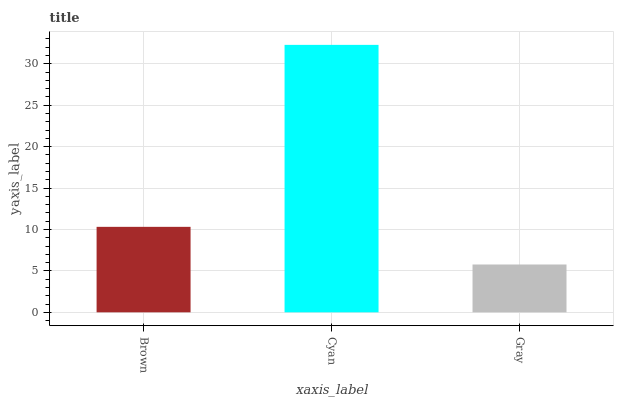Is Gray the minimum?
Answer yes or no. Yes. Is Cyan the maximum?
Answer yes or no. Yes. Is Cyan the minimum?
Answer yes or no. No. Is Gray the maximum?
Answer yes or no. No. Is Cyan greater than Gray?
Answer yes or no. Yes. Is Gray less than Cyan?
Answer yes or no. Yes. Is Gray greater than Cyan?
Answer yes or no. No. Is Cyan less than Gray?
Answer yes or no. No. Is Brown the high median?
Answer yes or no. Yes. Is Brown the low median?
Answer yes or no. Yes. Is Cyan the high median?
Answer yes or no. No. Is Cyan the low median?
Answer yes or no. No. 